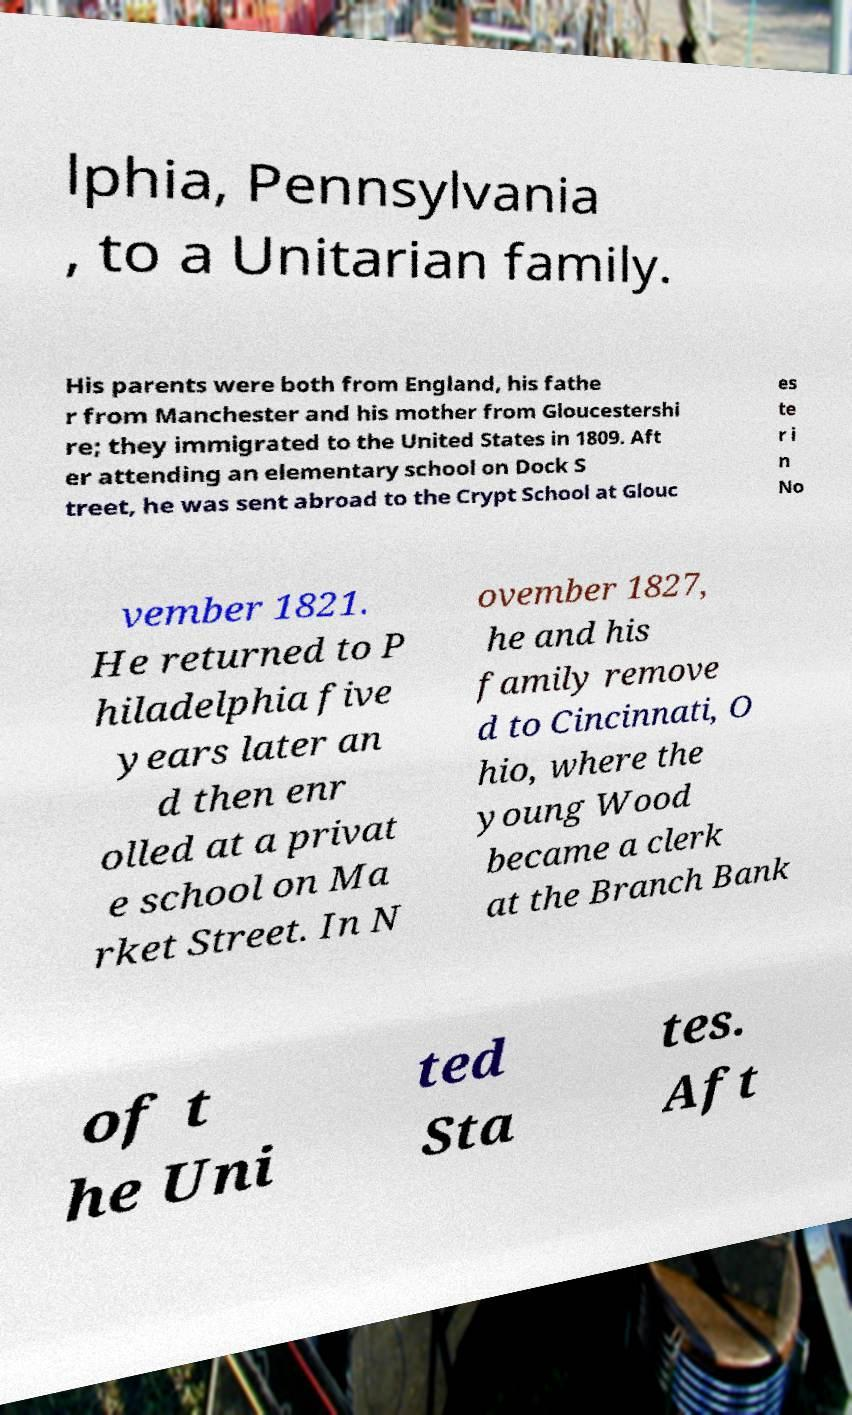Please identify and transcribe the text found in this image. lphia, Pennsylvania , to a Unitarian family. His parents were both from England, his fathe r from Manchester and his mother from Gloucestershi re; they immigrated to the United States in 1809. Aft er attending an elementary school on Dock S treet, he was sent abroad to the Crypt School at Glouc es te r i n No vember 1821. He returned to P hiladelphia five years later an d then enr olled at a privat e school on Ma rket Street. In N ovember 1827, he and his family remove d to Cincinnati, O hio, where the young Wood became a clerk at the Branch Bank of t he Uni ted Sta tes. Aft 